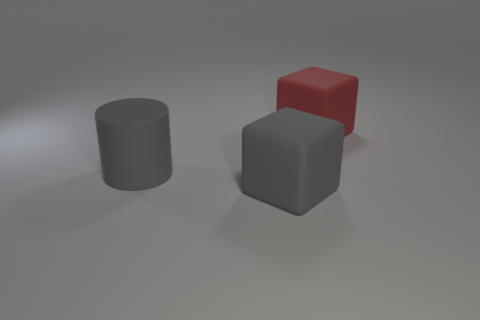Add 2 tiny blue matte spheres. How many objects exist? 5 Subtract 0 green cylinders. How many objects are left? 3 Subtract all blocks. How many objects are left? 1 Subtract all large gray blocks. Subtract all small shiny spheres. How many objects are left? 2 Add 3 large red blocks. How many large red blocks are left? 4 Add 1 big gray blocks. How many big gray blocks exist? 2 